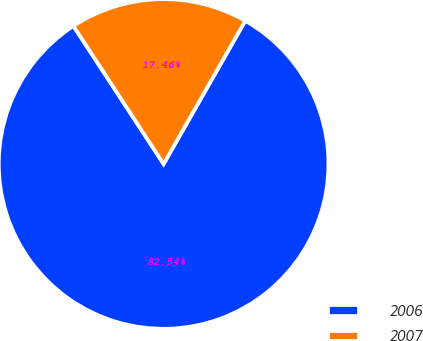<chart> <loc_0><loc_0><loc_500><loc_500><pie_chart><fcel>2006<fcel>2007<nl><fcel>82.54%<fcel>17.46%<nl></chart> 